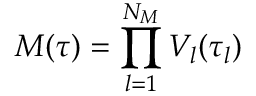Convert formula to latex. <formula><loc_0><loc_0><loc_500><loc_500>{ M ( \tau ) } = \prod _ { l = 1 } ^ { N _ { M } } V _ { l } ( \tau _ { l } )</formula> 